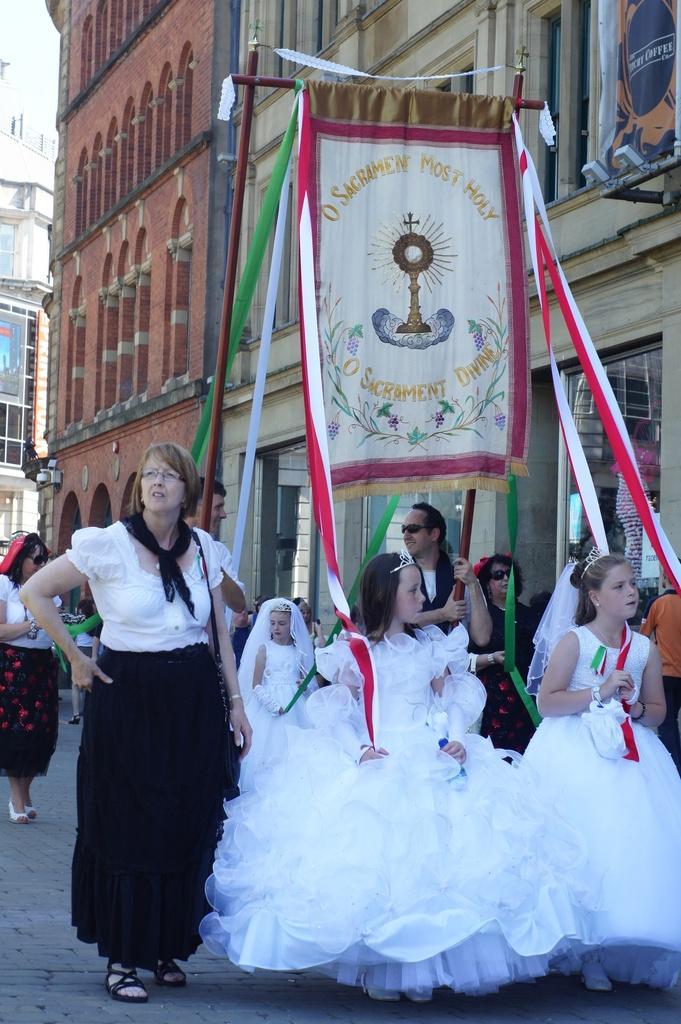Describe this image in one or two sentences. In this image few girls are wearing white dress. they are holding ribbons which are tied to the rod having a flag. A woman wearing a white top is wearing scarf and she is carrying a bag. Behind there are few persons walking on the path. Background there are few buildings. 